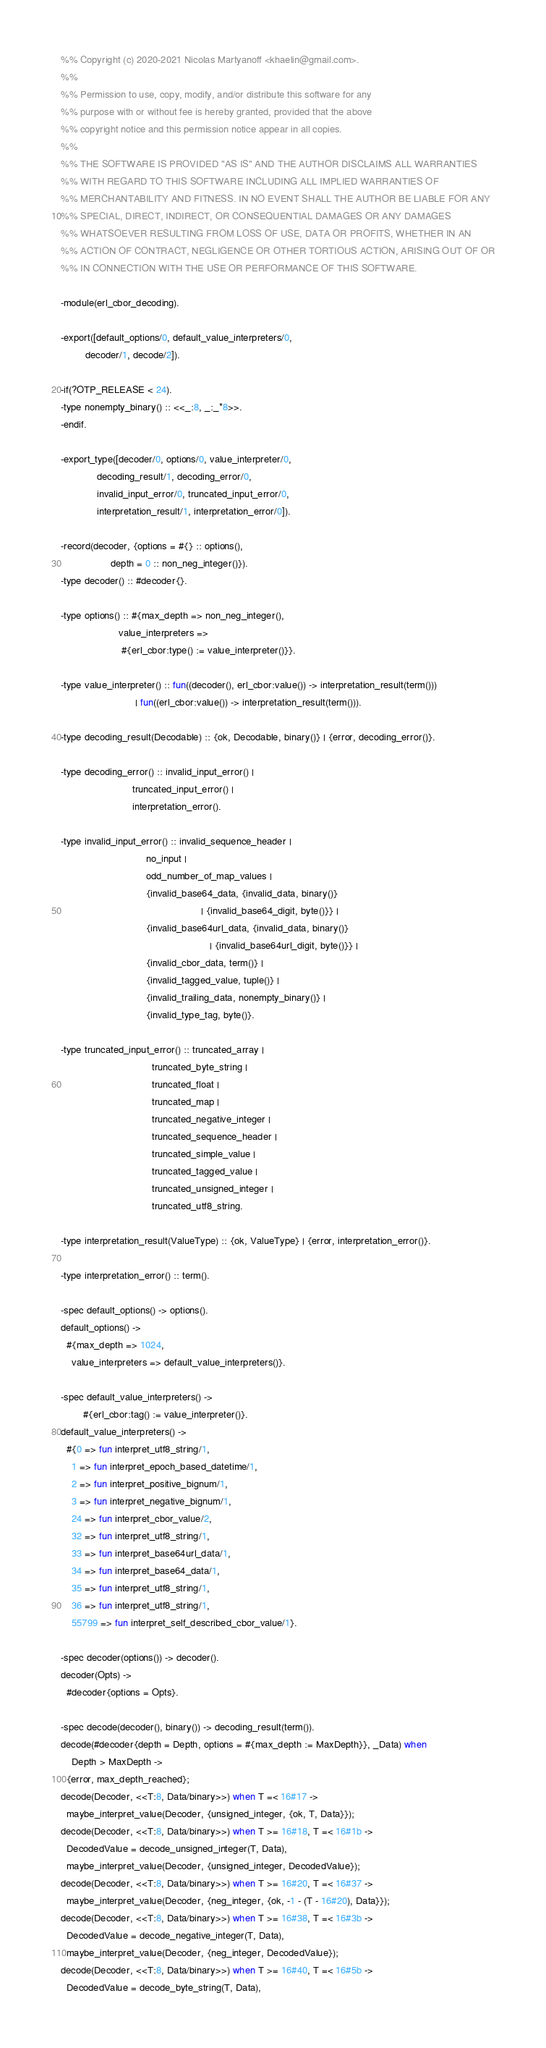<code> <loc_0><loc_0><loc_500><loc_500><_Erlang_>%% Copyright (c) 2020-2021 Nicolas Martyanoff <khaelin@gmail.com>.
%%
%% Permission to use, copy, modify, and/or distribute this software for any
%% purpose with or without fee is hereby granted, provided that the above
%% copyright notice and this permission notice appear in all copies.
%%
%% THE SOFTWARE IS PROVIDED "AS IS" AND THE AUTHOR DISCLAIMS ALL WARRANTIES
%% WITH REGARD TO THIS SOFTWARE INCLUDING ALL IMPLIED WARRANTIES OF
%% MERCHANTABILITY AND FITNESS. IN NO EVENT SHALL THE AUTHOR BE LIABLE FOR ANY
%% SPECIAL, DIRECT, INDIRECT, OR CONSEQUENTIAL DAMAGES OR ANY DAMAGES
%% WHATSOEVER RESULTING FROM LOSS OF USE, DATA OR PROFITS, WHETHER IN AN
%% ACTION OF CONTRACT, NEGLIGENCE OR OTHER TORTIOUS ACTION, ARISING OUT OF OR
%% IN CONNECTION WITH THE USE OR PERFORMANCE OF THIS SOFTWARE.

-module(erl_cbor_decoding).

-export([default_options/0, default_value_interpreters/0,
         decoder/1, decode/2]).

-if(?OTP_RELEASE < 24).
-type nonempty_binary() :: <<_:8, _:_*8>>.
-endif.

-export_type([decoder/0, options/0, value_interpreter/0,
             decoding_result/1, decoding_error/0,
             invalid_input_error/0, truncated_input_error/0,
             interpretation_result/1, interpretation_error/0]).

-record(decoder, {options = #{} :: options(),
                  depth = 0 :: non_neg_integer()}).
-type decoder() :: #decoder{}.

-type options() :: #{max_depth => non_neg_integer(),
                     value_interpreters =>
                      #{erl_cbor:type() := value_interpreter()}}.

-type value_interpreter() :: fun((decoder(), erl_cbor:value()) -> interpretation_result(term()))
                           | fun((erl_cbor:value()) -> interpretation_result(term())).

-type decoding_result(Decodable) :: {ok, Decodable, binary()} | {error, decoding_error()}.

-type decoding_error() :: invalid_input_error() |
                          truncated_input_error() |
                          interpretation_error().

-type invalid_input_error() :: invalid_sequence_header |
                               no_input |
                               odd_number_of_map_values |
                               {invalid_base64_data, {invalid_data, binary()}
                                                   | {invalid_base64_digit, byte()}} |
                               {invalid_base64url_data, {invalid_data, binary()}
                                                      | {invalid_base64url_digit, byte()}} |
                               {invalid_cbor_data, term()} |
                               {invalid_tagged_value, tuple()} |
                               {invalid_trailing_data, nonempty_binary()} |
                               {invalid_type_tag, byte()}.

-type truncated_input_error() :: truncated_array |
                                 truncated_byte_string |
                                 truncated_float |
                                 truncated_map |
                                 truncated_negative_integer |
                                 truncated_sequence_header |
                                 truncated_simple_value |
                                 truncated_tagged_value |
                                 truncated_unsigned_integer |
                                 truncated_utf8_string.

-type interpretation_result(ValueType) :: {ok, ValueType} | {error, interpretation_error()}.

-type interpretation_error() :: term().

-spec default_options() -> options().
default_options() ->
  #{max_depth => 1024,
    value_interpreters => default_value_interpreters()}.

-spec default_value_interpreters() ->
        #{erl_cbor:tag() := value_interpreter()}.
default_value_interpreters() ->
  #{0 => fun interpret_utf8_string/1,
    1 => fun interpret_epoch_based_datetime/1,
    2 => fun interpret_positive_bignum/1,
    3 => fun interpret_negative_bignum/1,
    24 => fun interpret_cbor_value/2,
    32 => fun interpret_utf8_string/1,
    33 => fun interpret_base64url_data/1,
    34 => fun interpret_base64_data/1,
    35 => fun interpret_utf8_string/1,
    36 => fun interpret_utf8_string/1,
    55799 => fun interpret_self_described_cbor_value/1}.

-spec decoder(options()) -> decoder().
decoder(Opts) ->
  #decoder{options = Opts}.

-spec decode(decoder(), binary()) -> decoding_result(term()).
decode(#decoder{depth = Depth, options = #{max_depth := MaxDepth}}, _Data) when
    Depth > MaxDepth ->
  {error, max_depth_reached};
decode(Decoder, <<T:8, Data/binary>>) when T =< 16#17 ->
  maybe_interpret_value(Decoder, {unsigned_integer, {ok, T, Data}});
decode(Decoder, <<T:8, Data/binary>>) when T >= 16#18, T =< 16#1b ->
  DecodedValue = decode_unsigned_integer(T, Data),
  maybe_interpret_value(Decoder, {unsigned_integer, DecodedValue});
decode(Decoder, <<T:8, Data/binary>>) when T >= 16#20, T =< 16#37 ->
  maybe_interpret_value(Decoder, {neg_integer, {ok, -1 - (T - 16#20), Data}});
decode(Decoder, <<T:8, Data/binary>>) when T >= 16#38, T =< 16#3b ->
  DecodedValue = decode_negative_integer(T, Data),
  maybe_interpret_value(Decoder, {neg_integer, DecodedValue});
decode(Decoder, <<T:8, Data/binary>>) when T >= 16#40, T =< 16#5b ->
  DecodedValue = decode_byte_string(T, Data),</code> 